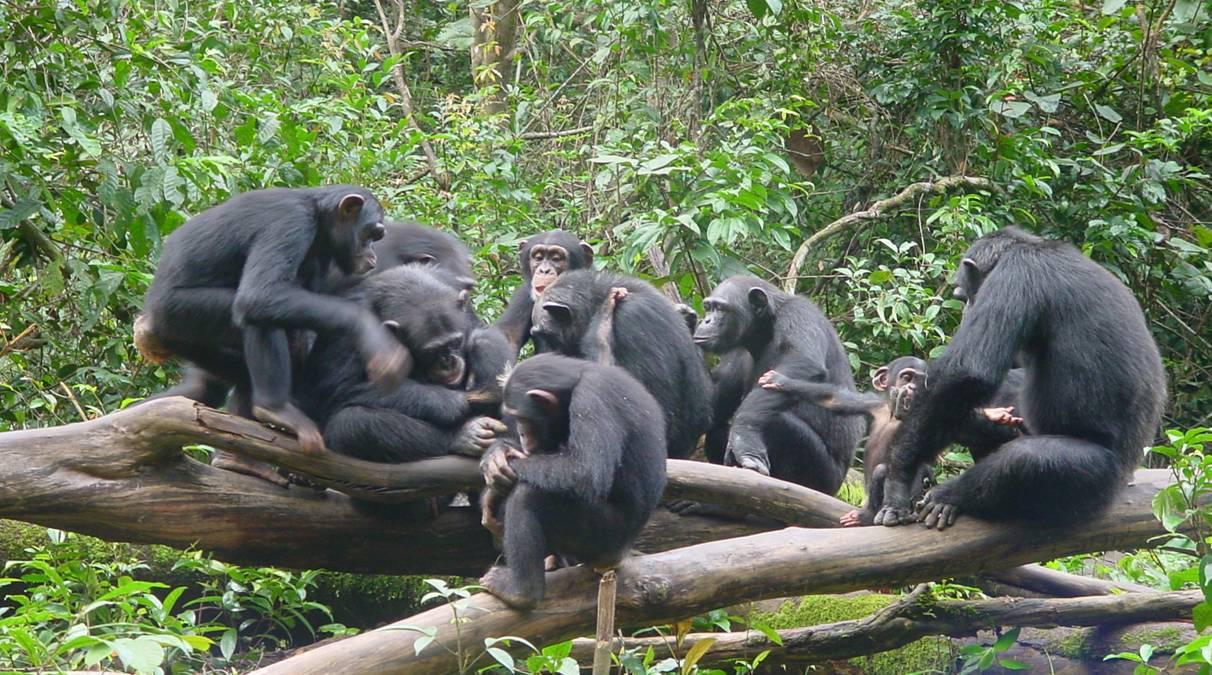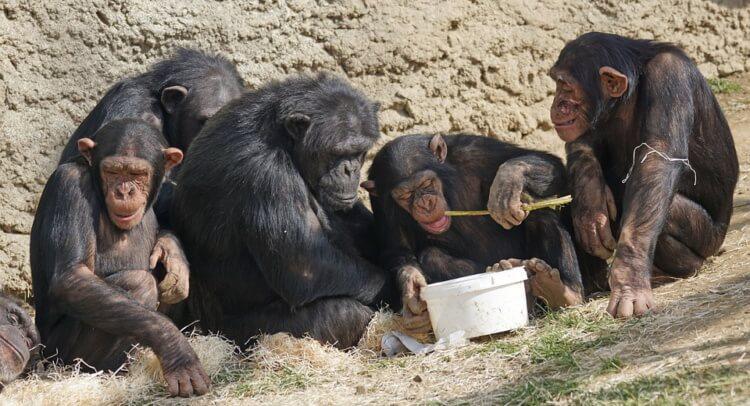The first image is the image on the left, the second image is the image on the right. Examine the images to the left and right. Is the description "there are chimps with open wide moths displayed" accurate? Answer yes or no. No. The first image is the image on the left, the second image is the image on the right. Considering the images on both sides, is "An image shows a horizontal row of exactly five chimps." valid? Answer yes or no. Yes. 